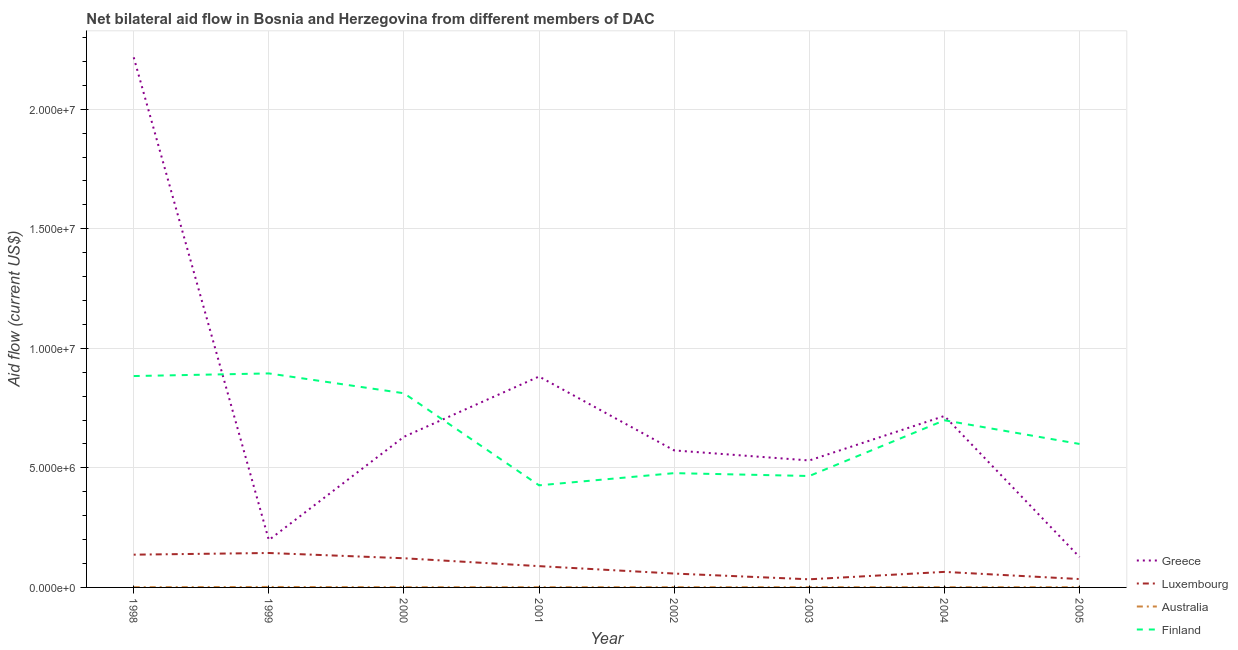Is the number of lines equal to the number of legend labels?
Provide a succinct answer. Yes. What is the amount of aid given by greece in 2001?
Give a very brief answer. 8.82e+06. Across all years, what is the maximum amount of aid given by luxembourg?
Offer a very short reply. 1.44e+06. Across all years, what is the minimum amount of aid given by luxembourg?
Your response must be concise. 3.40e+05. What is the total amount of aid given by luxembourg in the graph?
Keep it short and to the point. 6.84e+06. What is the difference between the amount of aid given by australia in 1998 and that in 2001?
Make the answer very short. 0. What is the difference between the amount of aid given by finland in 2000 and the amount of aid given by luxembourg in 1999?
Your response must be concise. 6.68e+06. What is the average amount of aid given by greece per year?
Offer a terse response. 7.34e+06. In the year 2000, what is the difference between the amount of aid given by greece and amount of aid given by australia?
Your response must be concise. 6.29e+06. In how many years, is the amount of aid given by luxembourg greater than 15000000 US$?
Offer a terse response. 0. What is the ratio of the amount of aid given by luxembourg in 1998 to that in 2002?
Your answer should be compact. 2.36. Is the amount of aid given by greece in 1998 less than that in 2005?
Offer a very short reply. No. What is the difference between the highest and the lowest amount of aid given by australia?
Make the answer very short. 10000. In how many years, is the amount of aid given by greece greater than the average amount of aid given by greece taken over all years?
Your answer should be compact. 2. Is it the case that in every year, the sum of the amount of aid given by australia and amount of aid given by greece is greater than the sum of amount of aid given by luxembourg and amount of aid given by finland?
Your answer should be compact. No. Is it the case that in every year, the sum of the amount of aid given by greece and amount of aid given by luxembourg is greater than the amount of aid given by australia?
Your answer should be compact. Yes. Does the amount of aid given by australia monotonically increase over the years?
Give a very brief answer. No. Is the amount of aid given by finland strictly greater than the amount of aid given by luxembourg over the years?
Provide a short and direct response. Yes. What is the difference between two consecutive major ticks on the Y-axis?
Offer a very short reply. 5.00e+06. Are the values on the major ticks of Y-axis written in scientific E-notation?
Provide a succinct answer. Yes. Does the graph contain any zero values?
Your response must be concise. No. Does the graph contain grids?
Keep it short and to the point. Yes. Where does the legend appear in the graph?
Make the answer very short. Bottom right. How many legend labels are there?
Provide a succinct answer. 4. How are the legend labels stacked?
Give a very brief answer. Vertical. What is the title of the graph?
Your answer should be compact. Net bilateral aid flow in Bosnia and Herzegovina from different members of DAC. Does "United States" appear as one of the legend labels in the graph?
Offer a very short reply. No. What is the Aid flow (current US$) in Greece in 1998?
Your answer should be very brief. 2.22e+07. What is the Aid flow (current US$) of Luxembourg in 1998?
Keep it short and to the point. 1.37e+06. What is the Aid flow (current US$) in Australia in 1998?
Make the answer very short. 10000. What is the Aid flow (current US$) of Finland in 1998?
Your answer should be compact. 8.84e+06. What is the Aid flow (current US$) in Greece in 1999?
Give a very brief answer. 1.98e+06. What is the Aid flow (current US$) of Luxembourg in 1999?
Your response must be concise. 1.44e+06. What is the Aid flow (current US$) in Finland in 1999?
Offer a terse response. 8.95e+06. What is the Aid flow (current US$) in Greece in 2000?
Provide a succinct answer. 6.30e+06. What is the Aid flow (current US$) in Luxembourg in 2000?
Your answer should be very brief. 1.22e+06. What is the Aid flow (current US$) of Australia in 2000?
Your answer should be compact. 10000. What is the Aid flow (current US$) in Finland in 2000?
Provide a short and direct response. 8.12e+06. What is the Aid flow (current US$) of Greece in 2001?
Provide a succinct answer. 8.82e+06. What is the Aid flow (current US$) of Luxembourg in 2001?
Provide a short and direct response. 8.90e+05. What is the Aid flow (current US$) of Australia in 2001?
Offer a very short reply. 10000. What is the Aid flow (current US$) of Finland in 2001?
Give a very brief answer. 4.27e+06. What is the Aid flow (current US$) of Greece in 2002?
Give a very brief answer. 5.73e+06. What is the Aid flow (current US$) in Luxembourg in 2002?
Provide a succinct answer. 5.80e+05. What is the Aid flow (current US$) of Finland in 2002?
Give a very brief answer. 4.78e+06. What is the Aid flow (current US$) of Greece in 2003?
Ensure brevity in your answer.  5.31e+06. What is the Aid flow (current US$) of Finland in 2003?
Provide a succinct answer. 4.66e+06. What is the Aid flow (current US$) in Greece in 2004?
Give a very brief answer. 7.17e+06. What is the Aid flow (current US$) of Luxembourg in 2004?
Give a very brief answer. 6.50e+05. What is the Aid flow (current US$) in Australia in 2004?
Provide a short and direct response. 10000. What is the Aid flow (current US$) in Finland in 2004?
Provide a short and direct response. 6.99e+06. What is the Aid flow (current US$) of Greece in 2005?
Give a very brief answer. 1.27e+06. What is the Aid flow (current US$) of Finland in 2005?
Make the answer very short. 6.00e+06. Across all years, what is the maximum Aid flow (current US$) of Greece?
Ensure brevity in your answer.  2.22e+07. Across all years, what is the maximum Aid flow (current US$) in Luxembourg?
Make the answer very short. 1.44e+06. Across all years, what is the maximum Aid flow (current US$) of Finland?
Give a very brief answer. 8.95e+06. Across all years, what is the minimum Aid flow (current US$) of Greece?
Provide a short and direct response. 1.27e+06. Across all years, what is the minimum Aid flow (current US$) of Australia?
Offer a terse response. 10000. Across all years, what is the minimum Aid flow (current US$) in Finland?
Keep it short and to the point. 4.27e+06. What is the total Aid flow (current US$) in Greece in the graph?
Provide a short and direct response. 5.88e+07. What is the total Aid flow (current US$) in Luxembourg in the graph?
Your response must be concise. 6.84e+06. What is the total Aid flow (current US$) in Finland in the graph?
Ensure brevity in your answer.  5.26e+07. What is the difference between the Aid flow (current US$) of Greece in 1998 and that in 1999?
Offer a very short reply. 2.02e+07. What is the difference between the Aid flow (current US$) in Luxembourg in 1998 and that in 1999?
Offer a terse response. -7.00e+04. What is the difference between the Aid flow (current US$) of Greece in 1998 and that in 2000?
Your answer should be very brief. 1.59e+07. What is the difference between the Aid flow (current US$) in Finland in 1998 and that in 2000?
Provide a short and direct response. 7.20e+05. What is the difference between the Aid flow (current US$) of Greece in 1998 and that in 2001?
Your answer should be very brief. 1.34e+07. What is the difference between the Aid flow (current US$) in Luxembourg in 1998 and that in 2001?
Offer a very short reply. 4.80e+05. What is the difference between the Aid flow (current US$) in Finland in 1998 and that in 2001?
Your response must be concise. 4.57e+06. What is the difference between the Aid flow (current US$) of Greece in 1998 and that in 2002?
Ensure brevity in your answer.  1.64e+07. What is the difference between the Aid flow (current US$) in Luxembourg in 1998 and that in 2002?
Make the answer very short. 7.90e+05. What is the difference between the Aid flow (current US$) of Australia in 1998 and that in 2002?
Make the answer very short. 0. What is the difference between the Aid flow (current US$) of Finland in 1998 and that in 2002?
Ensure brevity in your answer.  4.06e+06. What is the difference between the Aid flow (current US$) of Greece in 1998 and that in 2003?
Your answer should be compact. 1.69e+07. What is the difference between the Aid flow (current US$) of Luxembourg in 1998 and that in 2003?
Your answer should be compact. 1.03e+06. What is the difference between the Aid flow (current US$) in Australia in 1998 and that in 2003?
Ensure brevity in your answer.  0. What is the difference between the Aid flow (current US$) of Finland in 1998 and that in 2003?
Your answer should be very brief. 4.18e+06. What is the difference between the Aid flow (current US$) of Greece in 1998 and that in 2004?
Ensure brevity in your answer.  1.50e+07. What is the difference between the Aid flow (current US$) of Luxembourg in 1998 and that in 2004?
Make the answer very short. 7.20e+05. What is the difference between the Aid flow (current US$) in Finland in 1998 and that in 2004?
Your response must be concise. 1.85e+06. What is the difference between the Aid flow (current US$) in Greece in 1998 and that in 2005?
Offer a very short reply. 2.09e+07. What is the difference between the Aid flow (current US$) in Luxembourg in 1998 and that in 2005?
Ensure brevity in your answer.  1.02e+06. What is the difference between the Aid flow (current US$) of Australia in 1998 and that in 2005?
Keep it short and to the point. 0. What is the difference between the Aid flow (current US$) in Finland in 1998 and that in 2005?
Ensure brevity in your answer.  2.84e+06. What is the difference between the Aid flow (current US$) in Greece in 1999 and that in 2000?
Your answer should be very brief. -4.32e+06. What is the difference between the Aid flow (current US$) of Luxembourg in 1999 and that in 2000?
Your response must be concise. 2.20e+05. What is the difference between the Aid flow (current US$) in Australia in 1999 and that in 2000?
Offer a very short reply. 10000. What is the difference between the Aid flow (current US$) in Finland in 1999 and that in 2000?
Ensure brevity in your answer.  8.30e+05. What is the difference between the Aid flow (current US$) in Greece in 1999 and that in 2001?
Offer a very short reply. -6.84e+06. What is the difference between the Aid flow (current US$) in Luxembourg in 1999 and that in 2001?
Your answer should be very brief. 5.50e+05. What is the difference between the Aid flow (current US$) of Australia in 1999 and that in 2001?
Offer a very short reply. 10000. What is the difference between the Aid flow (current US$) of Finland in 1999 and that in 2001?
Ensure brevity in your answer.  4.68e+06. What is the difference between the Aid flow (current US$) of Greece in 1999 and that in 2002?
Your answer should be compact. -3.75e+06. What is the difference between the Aid flow (current US$) in Luxembourg in 1999 and that in 2002?
Offer a terse response. 8.60e+05. What is the difference between the Aid flow (current US$) in Finland in 1999 and that in 2002?
Your answer should be very brief. 4.17e+06. What is the difference between the Aid flow (current US$) of Greece in 1999 and that in 2003?
Make the answer very short. -3.33e+06. What is the difference between the Aid flow (current US$) of Luxembourg in 1999 and that in 2003?
Your response must be concise. 1.10e+06. What is the difference between the Aid flow (current US$) of Australia in 1999 and that in 2003?
Your answer should be very brief. 10000. What is the difference between the Aid flow (current US$) in Finland in 1999 and that in 2003?
Keep it short and to the point. 4.29e+06. What is the difference between the Aid flow (current US$) of Greece in 1999 and that in 2004?
Provide a short and direct response. -5.19e+06. What is the difference between the Aid flow (current US$) in Luxembourg in 1999 and that in 2004?
Provide a succinct answer. 7.90e+05. What is the difference between the Aid flow (current US$) of Finland in 1999 and that in 2004?
Give a very brief answer. 1.96e+06. What is the difference between the Aid flow (current US$) of Greece in 1999 and that in 2005?
Your response must be concise. 7.10e+05. What is the difference between the Aid flow (current US$) of Luxembourg in 1999 and that in 2005?
Offer a terse response. 1.09e+06. What is the difference between the Aid flow (current US$) in Australia in 1999 and that in 2005?
Provide a succinct answer. 10000. What is the difference between the Aid flow (current US$) of Finland in 1999 and that in 2005?
Keep it short and to the point. 2.95e+06. What is the difference between the Aid flow (current US$) of Greece in 2000 and that in 2001?
Your answer should be compact. -2.52e+06. What is the difference between the Aid flow (current US$) of Finland in 2000 and that in 2001?
Keep it short and to the point. 3.85e+06. What is the difference between the Aid flow (current US$) of Greece in 2000 and that in 2002?
Your answer should be very brief. 5.70e+05. What is the difference between the Aid flow (current US$) in Luxembourg in 2000 and that in 2002?
Provide a succinct answer. 6.40e+05. What is the difference between the Aid flow (current US$) of Finland in 2000 and that in 2002?
Your answer should be very brief. 3.34e+06. What is the difference between the Aid flow (current US$) in Greece in 2000 and that in 2003?
Your response must be concise. 9.90e+05. What is the difference between the Aid flow (current US$) of Luxembourg in 2000 and that in 2003?
Make the answer very short. 8.80e+05. What is the difference between the Aid flow (current US$) of Finland in 2000 and that in 2003?
Ensure brevity in your answer.  3.46e+06. What is the difference between the Aid flow (current US$) of Greece in 2000 and that in 2004?
Keep it short and to the point. -8.70e+05. What is the difference between the Aid flow (current US$) in Luxembourg in 2000 and that in 2004?
Give a very brief answer. 5.70e+05. What is the difference between the Aid flow (current US$) of Finland in 2000 and that in 2004?
Make the answer very short. 1.13e+06. What is the difference between the Aid flow (current US$) of Greece in 2000 and that in 2005?
Your answer should be very brief. 5.03e+06. What is the difference between the Aid flow (current US$) in Luxembourg in 2000 and that in 2005?
Your response must be concise. 8.70e+05. What is the difference between the Aid flow (current US$) in Finland in 2000 and that in 2005?
Give a very brief answer. 2.12e+06. What is the difference between the Aid flow (current US$) of Greece in 2001 and that in 2002?
Provide a succinct answer. 3.09e+06. What is the difference between the Aid flow (current US$) in Luxembourg in 2001 and that in 2002?
Give a very brief answer. 3.10e+05. What is the difference between the Aid flow (current US$) of Finland in 2001 and that in 2002?
Give a very brief answer. -5.10e+05. What is the difference between the Aid flow (current US$) in Greece in 2001 and that in 2003?
Your answer should be very brief. 3.51e+06. What is the difference between the Aid flow (current US$) of Luxembourg in 2001 and that in 2003?
Provide a succinct answer. 5.50e+05. What is the difference between the Aid flow (current US$) of Australia in 2001 and that in 2003?
Keep it short and to the point. 0. What is the difference between the Aid flow (current US$) of Finland in 2001 and that in 2003?
Make the answer very short. -3.90e+05. What is the difference between the Aid flow (current US$) of Greece in 2001 and that in 2004?
Make the answer very short. 1.65e+06. What is the difference between the Aid flow (current US$) of Australia in 2001 and that in 2004?
Give a very brief answer. 0. What is the difference between the Aid flow (current US$) in Finland in 2001 and that in 2004?
Give a very brief answer. -2.72e+06. What is the difference between the Aid flow (current US$) of Greece in 2001 and that in 2005?
Ensure brevity in your answer.  7.55e+06. What is the difference between the Aid flow (current US$) in Luxembourg in 2001 and that in 2005?
Provide a succinct answer. 5.40e+05. What is the difference between the Aid flow (current US$) of Australia in 2001 and that in 2005?
Make the answer very short. 0. What is the difference between the Aid flow (current US$) in Finland in 2001 and that in 2005?
Your answer should be compact. -1.73e+06. What is the difference between the Aid flow (current US$) of Australia in 2002 and that in 2003?
Provide a short and direct response. 0. What is the difference between the Aid flow (current US$) of Greece in 2002 and that in 2004?
Keep it short and to the point. -1.44e+06. What is the difference between the Aid flow (current US$) of Luxembourg in 2002 and that in 2004?
Offer a very short reply. -7.00e+04. What is the difference between the Aid flow (current US$) in Australia in 2002 and that in 2004?
Ensure brevity in your answer.  0. What is the difference between the Aid flow (current US$) in Finland in 2002 and that in 2004?
Your response must be concise. -2.21e+06. What is the difference between the Aid flow (current US$) of Greece in 2002 and that in 2005?
Make the answer very short. 4.46e+06. What is the difference between the Aid flow (current US$) in Luxembourg in 2002 and that in 2005?
Keep it short and to the point. 2.30e+05. What is the difference between the Aid flow (current US$) of Finland in 2002 and that in 2005?
Give a very brief answer. -1.22e+06. What is the difference between the Aid flow (current US$) in Greece in 2003 and that in 2004?
Offer a very short reply. -1.86e+06. What is the difference between the Aid flow (current US$) of Luxembourg in 2003 and that in 2004?
Offer a terse response. -3.10e+05. What is the difference between the Aid flow (current US$) of Finland in 2003 and that in 2004?
Provide a succinct answer. -2.33e+06. What is the difference between the Aid flow (current US$) in Greece in 2003 and that in 2005?
Keep it short and to the point. 4.04e+06. What is the difference between the Aid flow (current US$) of Finland in 2003 and that in 2005?
Your answer should be very brief. -1.34e+06. What is the difference between the Aid flow (current US$) of Greece in 2004 and that in 2005?
Offer a terse response. 5.90e+06. What is the difference between the Aid flow (current US$) in Luxembourg in 2004 and that in 2005?
Offer a very short reply. 3.00e+05. What is the difference between the Aid flow (current US$) in Australia in 2004 and that in 2005?
Your answer should be very brief. 0. What is the difference between the Aid flow (current US$) in Finland in 2004 and that in 2005?
Offer a terse response. 9.90e+05. What is the difference between the Aid flow (current US$) in Greece in 1998 and the Aid flow (current US$) in Luxembourg in 1999?
Your answer should be very brief. 2.07e+07. What is the difference between the Aid flow (current US$) in Greece in 1998 and the Aid flow (current US$) in Australia in 1999?
Give a very brief answer. 2.22e+07. What is the difference between the Aid flow (current US$) of Greece in 1998 and the Aid flow (current US$) of Finland in 1999?
Make the answer very short. 1.32e+07. What is the difference between the Aid flow (current US$) in Luxembourg in 1998 and the Aid flow (current US$) in Australia in 1999?
Make the answer very short. 1.35e+06. What is the difference between the Aid flow (current US$) of Luxembourg in 1998 and the Aid flow (current US$) of Finland in 1999?
Give a very brief answer. -7.58e+06. What is the difference between the Aid flow (current US$) of Australia in 1998 and the Aid flow (current US$) of Finland in 1999?
Make the answer very short. -8.94e+06. What is the difference between the Aid flow (current US$) in Greece in 1998 and the Aid flow (current US$) in Luxembourg in 2000?
Your response must be concise. 2.10e+07. What is the difference between the Aid flow (current US$) of Greece in 1998 and the Aid flow (current US$) of Australia in 2000?
Give a very brief answer. 2.22e+07. What is the difference between the Aid flow (current US$) of Greece in 1998 and the Aid flow (current US$) of Finland in 2000?
Offer a terse response. 1.40e+07. What is the difference between the Aid flow (current US$) in Luxembourg in 1998 and the Aid flow (current US$) in Australia in 2000?
Provide a succinct answer. 1.36e+06. What is the difference between the Aid flow (current US$) of Luxembourg in 1998 and the Aid flow (current US$) of Finland in 2000?
Your answer should be very brief. -6.75e+06. What is the difference between the Aid flow (current US$) in Australia in 1998 and the Aid flow (current US$) in Finland in 2000?
Offer a terse response. -8.11e+06. What is the difference between the Aid flow (current US$) in Greece in 1998 and the Aid flow (current US$) in Luxembourg in 2001?
Provide a succinct answer. 2.13e+07. What is the difference between the Aid flow (current US$) of Greece in 1998 and the Aid flow (current US$) of Australia in 2001?
Your answer should be very brief. 2.22e+07. What is the difference between the Aid flow (current US$) in Greece in 1998 and the Aid flow (current US$) in Finland in 2001?
Offer a very short reply. 1.79e+07. What is the difference between the Aid flow (current US$) of Luxembourg in 1998 and the Aid flow (current US$) of Australia in 2001?
Your answer should be very brief. 1.36e+06. What is the difference between the Aid flow (current US$) in Luxembourg in 1998 and the Aid flow (current US$) in Finland in 2001?
Offer a very short reply. -2.90e+06. What is the difference between the Aid flow (current US$) in Australia in 1998 and the Aid flow (current US$) in Finland in 2001?
Make the answer very short. -4.26e+06. What is the difference between the Aid flow (current US$) of Greece in 1998 and the Aid flow (current US$) of Luxembourg in 2002?
Your answer should be very brief. 2.16e+07. What is the difference between the Aid flow (current US$) in Greece in 1998 and the Aid flow (current US$) in Australia in 2002?
Offer a terse response. 2.22e+07. What is the difference between the Aid flow (current US$) in Greece in 1998 and the Aid flow (current US$) in Finland in 2002?
Offer a very short reply. 1.74e+07. What is the difference between the Aid flow (current US$) of Luxembourg in 1998 and the Aid flow (current US$) of Australia in 2002?
Your response must be concise. 1.36e+06. What is the difference between the Aid flow (current US$) of Luxembourg in 1998 and the Aid flow (current US$) of Finland in 2002?
Your answer should be compact. -3.41e+06. What is the difference between the Aid flow (current US$) in Australia in 1998 and the Aid flow (current US$) in Finland in 2002?
Your answer should be very brief. -4.77e+06. What is the difference between the Aid flow (current US$) of Greece in 1998 and the Aid flow (current US$) of Luxembourg in 2003?
Make the answer very short. 2.18e+07. What is the difference between the Aid flow (current US$) in Greece in 1998 and the Aid flow (current US$) in Australia in 2003?
Give a very brief answer. 2.22e+07. What is the difference between the Aid flow (current US$) of Greece in 1998 and the Aid flow (current US$) of Finland in 2003?
Provide a short and direct response. 1.75e+07. What is the difference between the Aid flow (current US$) in Luxembourg in 1998 and the Aid flow (current US$) in Australia in 2003?
Provide a short and direct response. 1.36e+06. What is the difference between the Aid flow (current US$) in Luxembourg in 1998 and the Aid flow (current US$) in Finland in 2003?
Your answer should be compact. -3.29e+06. What is the difference between the Aid flow (current US$) in Australia in 1998 and the Aid flow (current US$) in Finland in 2003?
Your answer should be very brief. -4.65e+06. What is the difference between the Aid flow (current US$) in Greece in 1998 and the Aid flow (current US$) in Luxembourg in 2004?
Give a very brief answer. 2.15e+07. What is the difference between the Aid flow (current US$) of Greece in 1998 and the Aid flow (current US$) of Australia in 2004?
Ensure brevity in your answer.  2.22e+07. What is the difference between the Aid flow (current US$) of Greece in 1998 and the Aid flow (current US$) of Finland in 2004?
Provide a succinct answer. 1.52e+07. What is the difference between the Aid flow (current US$) in Luxembourg in 1998 and the Aid flow (current US$) in Australia in 2004?
Ensure brevity in your answer.  1.36e+06. What is the difference between the Aid flow (current US$) of Luxembourg in 1998 and the Aid flow (current US$) of Finland in 2004?
Make the answer very short. -5.62e+06. What is the difference between the Aid flow (current US$) in Australia in 1998 and the Aid flow (current US$) in Finland in 2004?
Give a very brief answer. -6.98e+06. What is the difference between the Aid flow (current US$) in Greece in 1998 and the Aid flow (current US$) in Luxembourg in 2005?
Provide a succinct answer. 2.18e+07. What is the difference between the Aid flow (current US$) in Greece in 1998 and the Aid flow (current US$) in Australia in 2005?
Ensure brevity in your answer.  2.22e+07. What is the difference between the Aid flow (current US$) in Greece in 1998 and the Aid flow (current US$) in Finland in 2005?
Offer a terse response. 1.62e+07. What is the difference between the Aid flow (current US$) in Luxembourg in 1998 and the Aid flow (current US$) in Australia in 2005?
Provide a succinct answer. 1.36e+06. What is the difference between the Aid flow (current US$) in Luxembourg in 1998 and the Aid flow (current US$) in Finland in 2005?
Provide a succinct answer. -4.63e+06. What is the difference between the Aid flow (current US$) in Australia in 1998 and the Aid flow (current US$) in Finland in 2005?
Your answer should be compact. -5.99e+06. What is the difference between the Aid flow (current US$) of Greece in 1999 and the Aid flow (current US$) of Luxembourg in 2000?
Ensure brevity in your answer.  7.60e+05. What is the difference between the Aid flow (current US$) in Greece in 1999 and the Aid flow (current US$) in Australia in 2000?
Ensure brevity in your answer.  1.97e+06. What is the difference between the Aid flow (current US$) in Greece in 1999 and the Aid flow (current US$) in Finland in 2000?
Your answer should be very brief. -6.14e+06. What is the difference between the Aid flow (current US$) in Luxembourg in 1999 and the Aid flow (current US$) in Australia in 2000?
Offer a very short reply. 1.43e+06. What is the difference between the Aid flow (current US$) in Luxembourg in 1999 and the Aid flow (current US$) in Finland in 2000?
Your answer should be very brief. -6.68e+06. What is the difference between the Aid flow (current US$) of Australia in 1999 and the Aid flow (current US$) of Finland in 2000?
Keep it short and to the point. -8.10e+06. What is the difference between the Aid flow (current US$) of Greece in 1999 and the Aid flow (current US$) of Luxembourg in 2001?
Offer a very short reply. 1.09e+06. What is the difference between the Aid flow (current US$) in Greece in 1999 and the Aid flow (current US$) in Australia in 2001?
Your response must be concise. 1.97e+06. What is the difference between the Aid flow (current US$) of Greece in 1999 and the Aid flow (current US$) of Finland in 2001?
Provide a succinct answer. -2.29e+06. What is the difference between the Aid flow (current US$) of Luxembourg in 1999 and the Aid flow (current US$) of Australia in 2001?
Keep it short and to the point. 1.43e+06. What is the difference between the Aid flow (current US$) in Luxembourg in 1999 and the Aid flow (current US$) in Finland in 2001?
Keep it short and to the point. -2.83e+06. What is the difference between the Aid flow (current US$) of Australia in 1999 and the Aid flow (current US$) of Finland in 2001?
Your answer should be very brief. -4.25e+06. What is the difference between the Aid flow (current US$) of Greece in 1999 and the Aid flow (current US$) of Luxembourg in 2002?
Give a very brief answer. 1.40e+06. What is the difference between the Aid flow (current US$) in Greece in 1999 and the Aid flow (current US$) in Australia in 2002?
Your answer should be compact. 1.97e+06. What is the difference between the Aid flow (current US$) in Greece in 1999 and the Aid flow (current US$) in Finland in 2002?
Provide a succinct answer. -2.80e+06. What is the difference between the Aid flow (current US$) in Luxembourg in 1999 and the Aid flow (current US$) in Australia in 2002?
Ensure brevity in your answer.  1.43e+06. What is the difference between the Aid flow (current US$) in Luxembourg in 1999 and the Aid flow (current US$) in Finland in 2002?
Your response must be concise. -3.34e+06. What is the difference between the Aid flow (current US$) in Australia in 1999 and the Aid flow (current US$) in Finland in 2002?
Provide a succinct answer. -4.76e+06. What is the difference between the Aid flow (current US$) in Greece in 1999 and the Aid flow (current US$) in Luxembourg in 2003?
Provide a succinct answer. 1.64e+06. What is the difference between the Aid flow (current US$) in Greece in 1999 and the Aid flow (current US$) in Australia in 2003?
Provide a succinct answer. 1.97e+06. What is the difference between the Aid flow (current US$) in Greece in 1999 and the Aid flow (current US$) in Finland in 2003?
Your response must be concise. -2.68e+06. What is the difference between the Aid flow (current US$) of Luxembourg in 1999 and the Aid flow (current US$) of Australia in 2003?
Ensure brevity in your answer.  1.43e+06. What is the difference between the Aid flow (current US$) of Luxembourg in 1999 and the Aid flow (current US$) of Finland in 2003?
Give a very brief answer. -3.22e+06. What is the difference between the Aid flow (current US$) in Australia in 1999 and the Aid flow (current US$) in Finland in 2003?
Your response must be concise. -4.64e+06. What is the difference between the Aid flow (current US$) of Greece in 1999 and the Aid flow (current US$) of Luxembourg in 2004?
Give a very brief answer. 1.33e+06. What is the difference between the Aid flow (current US$) in Greece in 1999 and the Aid flow (current US$) in Australia in 2004?
Provide a short and direct response. 1.97e+06. What is the difference between the Aid flow (current US$) in Greece in 1999 and the Aid flow (current US$) in Finland in 2004?
Offer a terse response. -5.01e+06. What is the difference between the Aid flow (current US$) in Luxembourg in 1999 and the Aid flow (current US$) in Australia in 2004?
Give a very brief answer. 1.43e+06. What is the difference between the Aid flow (current US$) of Luxembourg in 1999 and the Aid flow (current US$) of Finland in 2004?
Give a very brief answer. -5.55e+06. What is the difference between the Aid flow (current US$) in Australia in 1999 and the Aid flow (current US$) in Finland in 2004?
Give a very brief answer. -6.97e+06. What is the difference between the Aid flow (current US$) of Greece in 1999 and the Aid flow (current US$) of Luxembourg in 2005?
Give a very brief answer. 1.63e+06. What is the difference between the Aid flow (current US$) of Greece in 1999 and the Aid flow (current US$) of Australia in 2005?
Give a very brief answer. 1.97e+06. What is the difference between the Aid flow (current US$) in Greece in 1999 and the Aid flow (current US$) in Finland in 2005?
Offer a terse response. -4.02e+06. What is the difference between the Aid flow (current US$) in Luxembourg in 1999 and the Aid flow (current US$) in Australia in 2005?
Ensure brevity in your answer.  1.43e+06. What is the difference between the Aid flow (current US$) in Luxembourg in 1999 and the Aid flow (current US$) in Finland in 2005?
Provide a succinct answer. -4.56e+06. What is the difference between the Aid flow (current US$) in Australia in 1999 and the Aid flow (current US$) in Finland in 2005?
Provide a succinct answer. -5.98e+06. What is the difference between the Aid flow (current US$) of Greece in 2000 and the Aid flow (current US$) of Luxembourg in 2001?
Your answer should be compact. 5.41e+06. What is the difference between the Aid flow (current US$) of Greece in 2000 and the Aid flow (current US$) of Australia in 2001?
Offer a terse response. 6.29e+06. What is the difference between the Aid flow (current US$) of Greece in 2000 and the Aid flow (current US$) of Finland in 2001?
Give a very brief answer. 2.03e+06. What is the difference between the Aid flow (current US$) in Luxembourg in 2000 and the Aid flow (current US$) in Australia in 2001?
Your answer should be very brief. 1.21e+06. What is the difference between the Aid flow (current US$) of Luxembourg in 2000 and the Aid flow (current US$) of Finland in 2001?
Provide a short and direct response. -3.05e+06. What is the difference between the Aid flow (current US$) of Australia in 2000 and the Aid flow (current US$) of Finland in 2001?
Give a very brief answer. -4.26e+06. What is the difference between the Aid flow (current US$) in Greece in 2000 and the Aid flow (current US$) in Luxembourg in 2002?
Offer a very short reply. 5.72e+06. What is the difference between the Aid flow (current US$) of Greece in 2000 and the Aid flow (current US$) of Australia in 2002?
Give a very brief answer. 6.29e+06. What is the difference between the Aid flow (current US$) of Greece in 2000 and the Aid flow (current US$) of Finland in 2002?
Make the answer very short. 1.52e+06. What is the difference between the Aid flow (current US$) of Luxembourg in 2000 and the Aid flow (current US$) of Australia in 2002?
Provide a succinct answer. 1.21e+06. What is the difference between the Aid flow (current US$) of Luxembourg in 2000 and the Aid flow (current US$) of Finland in 2002?
Provide a succinct answer. -3.56e+06. What is the difference between the Aid flow (current US$) of Australia in 2000 and the Aid flow (current US$) of Finland in 2002?
Your answer should be very brief. -4.77e+06. What is the difference between the Aid flow (current US$) of Greece in 2000 and the Aid flow (current US$) of Luxembourg in 2003?
Your response must be concise. 5.96e+06. What is the difference between the Aid flow (current US$) of Greece in 2000 and the Aid flow (current US$) of Australia in 2003?
Ensure brevity in your answer.  6.29e+06. What is the difference between the Aid flow (current US$) in Greece in 2000 and the Aid flow (current US$) in Finland in 2003?
Offer a very short reply. 1.64e+06. What is the difference between the Aid flow (current US$) of Luxembourg in 2000 and the Aid flow (current US$) of Australia in 2003?
Offer a very short reply. 1.21e+06. What is the difference between the Aid flow (current US$) of Luxembourg in 2000 and the Aid flow (current US$) of Finland in 2003?
Keep it short and to the point. -3.44e+06. What is the difference between the Aid flow (current US$) of Australia in 2000 and the Aid flow (current US$) of Finland in 2003?
Provide a succinct answer. -4.65e+06. What is the difference between the Aid flow (current US$) in Greece in 2000 and the Aid flow (current US$) in Luxembourg in 2004?
Keep it short and to the point. 5.65e+06. What is the difference between the Aid flow (current US$) of Greece in 2000 and the Aid flow (current US$) of Australia in 2004?
Your response must be concise. 6.29e+06. What is the difference between the Aid flow (current US$) in Greece in 2000 and the Aid flow (current US$) in Finland in 2004?
Provide a succinct answer. -6.90e+05. What is the difference between the Aid flow (current US$) of Luxembourg in 2000 and the Aid flow (current US$) of Australia in 2004?
Provide a succinct answer. 1.21e+06. What is the difference between the Aid flow (current US$) in Luxembourg in 2000 and the Aid flow (current US$) in Finland in 2004?
Keep it short and to the point. -5.77e+06. What is the difference between the Aid flow (current US$) of Australia in 2000 and the Aid flow (current US$) of Finland in 2004?
Ensure brevity in your answer.  -6.98e+06. What is the difference between the Aid flow (current US$) in Greece in 2000 and the Aid flow (current US$) in Luxembourg in 2005?
Your response must be concise. 5.95e+06. What is the difference between the Aid flow (current US$) of Greece in 2000 and the Aid flow (current US$) of Australia in 2005?
Offer a terse response. 6.29e+06. What is the difference between the Aid flow (current US$) in Luxembourg in 2000 and the Aid flow (current US$) in Australia in 2005?
Your response must be concise. 1.21e+06. What is the difference between the Aid flow (current US$) of Luxembourg in 2000 and the Aid flow (current US$) of Finland in 2005?
Ensure brevity in your answer.  -4.78e+06. What is the difference between the Aid flow (current US$) of Australia in 2000 and the Aid flow (current US$) of Finland in 2005?
Give a very brief answer. -5.99e+06. What is the difference between the Aid flow (current US$) in Greece in 2001 and the Aid flow (current US$) in Luxembourg in 2002?
Your answer should be very brief. 8.24e+06. What is the difference between the Aid flow (current US$) of Greece in 2001 and the Aid flow (current US$) of Australia in 2002?
Your response must be concise. 8.81e+06. What is the difference between the Aid flow (current US$) of Greece in 2001 and the Aid flow (current US$) of Finland in 2002?
Your answer should be very brief. 4.04e+06. What is the difference between the Aid flow (current US$) in Luxembourg in 2001 and the Aid flow (current US$) in Australia in 2002?
Your answer should be very brief. 8.80e+05. What is the difference between the Aid flow (current US$) in Luxembourg in 2001 and the Aid flow (current US$) in Finland in 2002?
Ensure brevity in your answer.  -3.89e+06. What is the difference between the Aid flow (current US$) in Australia in 2001 and the Aid flow (current US$) in Finland in 2002?
Your answer should be compact. -4.77e+06. What is the difference between the Aid flow (current US$) in Greece in 2001 and the Aid flow (current US$) in Luxembourg in 2003?
Your answer should be compact. 8.48e+06. What is the difference between the Aid flow (current US$) of Greece in 2001 and the Aid flow (current US$) of Australia in 2003?
Keep it short and to the point. 8.81e+06. What is the difference between the Aid flow (current US$) of Greece in 2001 and the Aid flow (current US$) of Finland in 2003?
Offer a terse response. 4.16e+06. What is the difference between the Aid flow (current US$) in Luxembourg in 2001 and the Aid flow (current US$) in Australia in 2003?
Your answer should be compact. 8.80e+05. What is the difference between the Aid flow (current US$) in Luxembourg in 2001 and the Aid flow (current US$) in Finland in 2003?
Give a very brief answer. -3.77e+06. What is the difference between the Aid flow (current US$) of Australia in 2001 and the Aid flow (current US$) of Finland in 2003?
Provide a short and direct response. -4.65e+06. What is the difference between the Aid flow (current US$) in Greece in 2001 and the Aid flow (current US$) in Luxembourg in 2004?
Give a very brief answer. 8.17e+06. What is the difference between the Aid flow (current US$) of Greece in 2001 and the Aid flow (current US$) of Australia in 2004?
Make the answer very short. 8.81e+06. What is the difference between the Aid flow (current US$) in Greece in 2001 and the Aid flow (current US$) in Finland in 2004?
Ensure brevity in your answer.  1.83e+06. What is the difference between the Aid flow (current US$) of Luxembourg in 2001 and the Aid flow (current US$) of Australia in 2004?
Give a very brief answer. 8.80e+05. What is the difference between the Aid flow (current US$) of Luxembourg in 2001 and the Aid flow (current US$) of Finland in 2004?
Your answer should be compact. -6.10e+06. What is the difference between the Aid flow (current US$) in Australia in 2001 and the Aid flow (current US$) in Finland in 2004?
Ensure brevity in your answer.  -6.98e+06. What is the difference between the Aid flow (current US$) of Greece in 2001 and the Aid flow (current US$) of Luxembourg in 2005?
Keep it short and to the point. 8.47e+06. What is the difference between the Aid flow (current US$) of Greece in 2001 and the Aid flow (current US$) of Australia in 2005?
Your answer should be very brief. 8.81e+06. What is the difference between the Aid flow (current US$) of Greece in 2001 and the Aid flow (current US$) of Finland in 2005?
Your answer should be compact. 2.82e+06. What is the difference between the Aid flow (current US$) of Luxembourg in 2001 and the Aid flow (current US$) of Australia in 2005?
Your answer should be very brief. 8.80e+05. What is the difference between the Aid flow (current US$) of Luxembourg in 2001 and the Aid flow (current US$) of Finland in 2005?
Your response must be concise. -5.11e+06. What is the difference between the Aid flow (current US$) of Australia in 2001 and the Aid flow (current US$) of Finland in 2005?
Your response must be concise. -5.99e+06. What is the difference between the Aid flow (current US$) of Greece in 2002 and the Aid flow (current US$) of Luxembourg in 2003?
Give a very brief answer. 5.39e+06. What is the difference between the Aid flow (current US$) of Greece in 2002 and the Aid flow (current US$) of Australia in 2003?
Provide a succinct answer. 5.72e+06. What is the difference between the Aid flow (current US$) in Greece in 2002 and the Aid flow (current US$) in Finland in 2003?
Your answer should be very brief. 1.07e+06. What is the difference between the Aid flow (current US$) in Luxembourg in 2002 and the Aid flow (current US$) in Australia in 2003?
Keep it short and to the point. 5.70e+05. What is the difference between the Aid flow (current US$) of Luxembourg in 2002 and the Aid flow (current US$) of Finland in 2003?
Ensure brevity in your answer.  -4.08e+06. What is the difference between the Aid flow (current US$) of Australia in 2002 and the Aid flow (current US$) of Finland in 2003?
Your answer should be compact. -4.65e+06. What is the difference between the Aid flow (current US$) of Greece in 2002 and the Aid flow (current US$) of Luxembourg in 2004?
Your answer should be very brief. 5.08e+06. What is the difference between the Aid flow (current US$) of Greece in 2002 and the Aid flow (current US$) of Australia in 2004?
Give a very brief answer. 5.72e+06. What is the difference between the Aid flow (current US$) of Greece in 2002 and the Aid flow (current US$) of Finland in 2004?
Provide a succinct answer. -1.26e+06. What is the difference between the Aid flow (current US$) of Luxembourg in 2002 and the Aid flow (current US$) of Australia in 2004?
Offer a terse response. 5.70e+05. What is the difference between the Aid flow (current US$) in Luxembourg in 2002 and the Aid flow (current US$) in Finland in 2004?
Provide a succinct answer. -6.41e+06. What is the difference between the Aid flow (current US$) in Australia in 2002 and the Aid flow (current US$) in Finland in 2004?
Provide a short and direct response. -6.98e+06. What is the difference between the Aid flow (current US$) in Greece in 2002 and the Aid flow (current US$) in Luxembourg in 2005?
Keep it short and to the point. 5.38e+06. What is the difference between the Aid flow (current US$) in Greece in 2002 and the Aid flow (current US$) in Australia in 2005?
Give a very brief answer. 5.72e+06. What is the difference between the Aid flow (current US$) of Luxembourg in 2002 and the Aid flow (current US$) of Australia in 2005?
Provide a succinct answer. 5.70e+05. What is the difference between the Aid flow (current US$) of Luxembourg in 2002 and the Aid flow (current US$) of Finland in 2005?
Provide a succinct answer. -5.42e+06. What is the difference between the Aid flow (current US$) of Australia in 2002 and the Aid flow (current US$) of Finland in 2005?
Ensure brevity in your answer.  -5.99e+06. What is the difference between the Aid flow (current US$) of Greece in 2003 and the Aid flow (current US$) of Luxembourg in 2004?
Your response must be concise. 4.66e+06. What is the difference between the Aid flow (current US$) of Greece in 2003 and the Aid flow (current US$) of Australia in 2004?
Offer a terse response. 5.30e+06. What is the difference between the Aid flow (current US$) in Greece in 2003 and the Aid flow (current US$) in Finland in 2004?
Your answer should be very brief. -1.68e+06. What is the difference between the Aid flow (current US$) of Luxembourg in 2003 and the Aid flow (current US$) of Australia in 2004?
Make the answer very short. 3.30e+05. What is the difference between the Aid flow (current US$) in Luxembourg in 2003 and the Aid flow (current US$) in Finland in 2004?
Keep it short and to the point. -6.65e+06. What is the difference between the Aid flow (current US$) in Australia in 2003 and the Aid flow (current US$) in Finland in 2004?
Ensure brevity in your answer.  -6.98e+06. What is the difference between the Aid flow (current US$) of Greece in 2003 and the Aid flow (current US$) of Luxembourg in 2005?
Make the answer very short. 4.96e+06. What is the difference between the Aid flow (current US$) of Greece in 2003 and the Aid flow (current US$) of Australia in 2005?
Offer a very short reply. 5.30e+06. What is the difference between the Aid flow (current US$) in Greece in 2003 and the Aid flow (current US$) in Finland in 2005?
Make the answer very short. -6.90e+05. What is the difference between the Aid flow (current US$) of Luxembourg in 2003 and the Aid flow (current US$) of Finland in 2005?
Your response must be concise. -5.66e+06. What is the difference between the Aid flow (current US$) in Australia in 2003 and the Aid flow (current US$) in Finland in 2005?
Provide a succinct answer. -5.99e+06. What is the difference between the Aid flow (current US$) in Greece in 2004 and the Aid flow (current US$) in Luxembourg in 2005?
Provide a short and direct response. 6.82e+06. What is the difference between the Aid flow (current US$) in Greece in 2004 and the Aid flow (current US$) in Australia in 2005?
Give a very brief answer. 7.16e+06. What is the difference between the Aid flow (current US$) in Greece in 2004 and the Aid flow (current US$) in Finland in 2005?
Give a very brief answer. 1.17e+06. What is the difference between the Aid flow (current US$) in Luxembourg in 2004 and the Aid flow (current US$) in Australia in 2005?
Give a very brief answer. 6.40e+05. What is the difference between the Aid flow (current US$) in Luxembourg in 2004 and the Aid flow (current US$) in Finland in 2005?
Give a very brief answer. -5.35e+06. What is the difference between the Aid flow (current US$) in Australia in 2004 and the Aid flow (current US$) in Finland in 2005?
Make the answer very short. -5.99e+06. What is the average Aid flow (current US$) of Greece per year?
Ensure brevity in your answer.  7.34e+06. What is the average Aid flow (current US$) in Luxembourg per year?
Your answer should be compact. 8.55e+05. What is the average Aid flow (current US$) of Australia per year?
Your answer should be very brief. 1.12e+04. What is the average Aid flow (current US$) in Finland per year?
Your answer should be compact. 6.58e+06. In the year 1998, what is the difference between the Aid flow (current US$) of Greece and Aid flow (current US$) of Luxembourg?
Offer a terse response. 2.08e+07. In the year 1998, what is the difference between the Aid flow (current US$) in Greece and Aid flow (current US$) in Australia?
Offer a very short reply. 2.22e+07. In the year 1998, what is the difference between the Aid flow (current US$) in Greece and Aid flow (current US$) in Finland?
Provide a succinct answer. 1.33e+07. In the year 1998, what is the difference between the Aid flow (current US$) in Luxembourg and Aid flow (current US$) in Australia?
Give a very brief answer. 1.36e+06. In the year 1998, what is the difference between the Aid flow (current US$) in Luxembourg and Aid flow (current US$) in Finland?
Keep it short and to the point. -7.47e+06. In the year 1998, what is the difference between the Aid flow (current US$) of Australia and Aid flow (current US$) of Finland?
Make the answer very short. -8.83e+06. In the year 1999, what is the difference between the Aid flow (current US$) of Greece and Aid flow (current US$) of Luxembourg?
Ensure brevity in your answer.  5.40e+05. In the year 1999, what is the difference between the Aid flow (current US$) of Greece and Aid flow (current US$) of Australia?
Your response must be concise. 1.96e+06. In the year 1999, what is the difference between the Aid flow (current US$) in Greece and Aid flow (current US$) in Finland?
Offer a very short reply. -6.97e+06. In the year 1999, what is the difference between the Aid flow (current US$) in Luxembourg and Aid flow (current US$) in Australia?
Offer a terse response. 1.42e+06. In the year 1999, what is the difference between the Aid flow (current US$) of Luxembourg and Aid flow (current US$) of Finland?
Provide a short and direct response. -7.51e+06. In the year 1999, what is the difference between the Aid flow (current US$) of Australia and Aid flow (current US$) of Finland?
Your answer should be compact. -8.93e+06. In the year 2000, what is the difference between the Aid flow (current US$) of Greece and Aid flow (current US$) of Luxembourg?
Your answer should be very brief. 5.08e+06. In the year 2000, what is the difference between the Aid flow (current US$) of Greece and Aid flow (current US$) of Australia?
Provide a short and direct response. 6.29e+06. In the year 2000, what is the difference between the Aid flow (current US$) in Greece and Aid flow (current US$) in Finland?
Give a very brief answer. -1.82e+06. In the year 2000, what is the difference between the Aid flow (current US$) in Luxembourg and Aid flow (current US$) in Australia?
Give a very brief answer. 1.21e+06. In the year 2000, what is the difference between the Aid flow (current US$) in Luxembourg and Aid flow (current US$) in Finland?
Your response must be concise. -6.90e+06. In the year 2000, what is the difference between the Aid flow (current US$) in Australia and Aid flow (current US$) in Finland?
Provide a succinct answer. -8.11e+06. In the year 2001, what is the difference between the Aid flow (current US$) in Greece and Aid flow (current US$) in Luxembourg?
Offer a terse response. 7.93e+06. In the year 2001, what is the difference between the Aid flow (current US$) of Greece and Aid flow (current US$) of Australia?
Your response must be concise. 8.81e+06. In the year 2001, what is the difference between the Aid flow (current US$) of Greece and Aid flow (current US$) of Finland?
Give a very brief answer. 4.55e+06. In the year 2001, what is the difference between the Aid flow (current US$) of Luxembourg and Aid flow (current US$) of Australia?
Provide a succinct answer. 8.80e+05. In the year 2001, what is the difference between the Aid flow (current US$) in Luxembourg and Aid flow (current US$) in Finland?
Offer a terse response. -3.38e+06. In the year 2001, what is the difference between the Aid flow (current US$) in Australia and Aid flow (current US$) in Finland?
Offer a very short reply. -4.26e+06. In the year 2002, what is the difference between the Aid flow (current US$) in Greece and Aid flow (current US$) in Luxembourg?
Your answer should be very brief. 5.15e+06. In the year 2002, what is the difference between the Aid flow (current US$) in Greece and Aid flow (current US$) in Australia?
Keep it short and to the point. 5.72e+06. In the year 2002, what is the difference between the Aid flow (current US$) in Greece and Aid flow (current US$) in Finland?
Provide a short and direct response. 9.50e+05. In the year 2002, what is the difference between the Aid flow (current US$) of Luxembourg and Aid flow (current US$) of Australia?
Ensure brevity in your answer.  5.70e+05. In the year 2002, what is the difference between the Aid flow (current US$) of Luxembourg and Aid flow (current US$) of Finland?
Provide a succinct answer. -4.20e+06. In the year 2002, what is the difference between the Aid flow (current US$) in Australia and Aid flow (current US$) in Finland?
Keep it short and to the point. -4.77e+06. In the year 2003, what is the difference between the Aid flow (current US$) in Greece and Aid flow (current US$) in Luxembourg?
Offer a very short reply. 4.97e+06. In the year 2003, what is the difference between the Aid flow (current US$) in Greece and Aid flow (current US$) in Australia?
Offer a terse response. 5.30e+06. In the year 2003, what is the difference between the Aid flow (current US$) of Greece and Aid flow (current US$) of Finland?
Offer a very short reply. 6.50e+05. In the year 2003, what is the difference between the Aid flow (current US$) in Luxembourg and Aid flow (current US$) in Australia?
Your answer should be compact. 3.30e+05. In the year 2003, what is the difference between the Aid flow (current US$) in Luxembourg and Aid flow (current US$) in Finland?
Give a very brief answer. -4.32e+06. In the year 2003, what is the difference between the Aid flow (current US$) of Australia and Aid flow (current US$) of Finland?
Make the answer very short. -4.65e+06. In the year 2004, what is the difference between the Aid flow (current US$) of Greece and Aid flow (current US$) of Luxembourg?
Your answer should be compact. 6.52e+06. In the year 2004, what is the difference between the Aid flow (current US$) in Greece and Aid flow (current US$) in Australia?
Keep it short and to the point. 7.16e+06. In the year 2004, what is the difference between the Aid flow (current US$) of Luxembourg and Aid flow (current US$) of Australia?
Provide a short and direct response. 6.40e+05. In the year 2004, what is the difference between the Aid flow (current US$) in Luxembourg and Aid flow (current US$) in Finland?
Offer a very short reply. -6.34e+06. In the year 2004, what is the difference between the Aid flow (current US$) in Australia and Aid flow (current US$) in Finland?
Your response must be concise. -6.98e+06. In the year 2005, what is the difference between the Aid flow (current US$) of Greece and Aid flow (current US$) of Luxembourg?
Your answer should be very brief. 9.20e+05. In the year 2005, what is the difference between the Aid flow (current US$) in Greece and Aid flow (current US$) in Australia?
Offer a terse response. 1.26e+06. In the year 2005, what is the difference between the Aid flow (current US$) of Greece and Aid flow (current US$) of Finland?
Make the answer very short. -4.73e+06. In the year 2005, what is the difference between the Aid flow (current US$) in Luxembourg and Aid flow (current US$) in Australia?
Provide a short and direct response. 3.40e+05. In the year 2005, what is the difference between the Aid flow (current US$) in Luxembourg and Aid flow (current US$) in Finland?
Your answer should be very brief. -5.65e+06. In the year 2005, what is the difference between the Aid flow (current US$) in Australia and Aid flow (current US$) in Finland?
Keep it short and to the point. -5.99e+06. What is the ratio of the Aid flow (current US$) in Greece in 1998 to that in 1999?
Keep it short and to the point. 11.2. What is the ratio of the Aid flow (current US$) of Luxembourg in 1998 to that in 1999?
Keep it short and to the point. 0.95. What is the ratio of the Aid flow (current US$) in Finland in 1998 to that in 1999?
Offer a very short reply. 0.99. What is the ratio of the Aid flow (current US$) in Greece in 1998 to that in 2000?
Offer a terse response. 3.52. What is the ratio of the Aid flow (current US$) of Luxembourg in 1998 to that in 2000?
Offer a very short reply. 1.12. What is the ratio of the Aid flow (current US$) in Australia in 1998 to that in 2000?
Your answer should be compact. 1. What is the ratio of the Aid flow (current US$) in Finland in 1998 to that in 2000?
Offer a terse response. 1.09. What is the ratio of the Aid flow (current US$) of Greece in 1998 to that in 2001?
Make the answer very short. 2.51. What is the ratio of the Aid flow (current US$) of Luxembourg in 1998 to that in 2001?
Provide a succinct answer. 1.54. What is the ratio of the Aid flow (current US$) of Finland in 1998 to that in 2001?
Provide a short and direct response. 2.07. What is the ratio of the Aid flow (current US$) of Greece in 1998 to that in 2002?
Keep it short and to the point. 3.87. What is the ratio of the Aid flow (current US$) in Luxembourg in 1998 to that in 2002?
Keep it short and to the point. 2.36. What is the ratio of the Aid flow (current US$) of Finland in 1998 to that in 2002?
Keep it short and to the point. 1.85. What is the ratio of the Aid flow (current US$) in Greece in 1998 to that in 2003?
Provide a succinct answer. 4.18. What is the ratio of the Aid flow (current US$) of Luxembourg in 1998 to that in 2003?
Offer a terse response. 4.03. What is the ratio of the Aid flow (current US$) in Australia in 1998 to that in 2003?
Give a very brief answer. 1. What is the ratio of the Aid flow (current US$) of Finland in 1998 to that in 2003?
Give a very brief answer. 1.9. What is the ratio of the Aid flow (current US$) in Greece in 1998 to that in 2004?
Make the answer very short. 3.09. What is the ratio of the Aid flow (current US$) of Luxembourg in 1998 to that in 2004?
Provide a short and direct response. 2.11. What is the ratio of the Aid flow (current US$) in Finland in 1998 to that in 2004?
Keep it short and to the point. 1.26. What is the ratio of the Aid flow (current US$) of Greece in 1998 to that in 2005?
Your response must be concise. 17.46. What is the ratio of the Aid flow (current US$) in Luxembourg in 1998 to that in 2005?
Ensure brevity in your answer.  3.91. What is the ratio of the Aid flow (current US$) of Australia in 1998 to that in 2005?
Make the answer very short. 1. What is the ratio of the Aid flow (current US$) in Finland in 1998 to that in 2005?
Give a very brief answer. 1.47. What is the ratio of the Aid flow (current US$) in Greece in 1999 to that in 2000?
Provide a succinct answer. 0.31. What is the ratio of the Aid flow (current US$) in Luxembourg in 1999 to that in 2000?
Provide a short and direct response. 1.18. What is the ratio of the Aid flow (current US$) in Finland in 1999 to that in 2000?
Provide a succinct answer. 1.1. What is the ratio of the Aid flow (current US$) in Greece in 1999 to that in 2001?
Your answer should be very brief. 0.22. What is the ratio of the Aid flow (current US$) of Luxembourg in 1999 to that in 2001?
Offer a terse response. 1.62. What is the ratio of the Aid flow (current US$) in Australia in 1999 to that in 2001?
Ensure brevity in your answer.  2. What is the ratio of the Aid flow (current US$) of Finland in 1999 to that in 2001?
Provide a short and direct response. 2.1. What is the ratio of the Aid flow (current US$) of Greece in 1999 to that in 2002?
Provide a short and direct response. 0.35. What is the ratio of the Aid flow (current US$) in Luxembourg in 1999 to that in 2002?
Offer a terse response. 2.48. What is the ratio of the Aid flow (current US$) of Australia in 1999 to that in 2002?
Give a very brief answer. 2. What is the ratio of the Aid flow (current US$) of Finland in 1999 to that in 2002?
Provide a short and direct response. 1.87. What is the ratio of the Aid flow (current US$) in Greece in 1999 to that in 2003?
Provide a succinct answer. 0.37. What is the ratio of the Aid flow (current US$) of Luxembourg in 1999 to that in 2003?
Give a very brief answer. 4.24. What is the ratio of the Aid flow (current US$) in Finland in 1999 to that in 2003?
Ensure brevity in your answer.  1.92. What is the ratio of the Aid flow (current US$) in Greece in 1999 to that in 2004?
Your answer should be very brief. 0.28. What is the ratio of the Aid flow (current US$) of Luxembourg in 1999 to that in 2004?
Give a very brief answer. 2.22. What is the ratio of the Aid flow (current US$) in Australia in 1999 to that in 2004?
Keep it short and to the point. 2. What is the ratio of the Aid flow (current US$) of Finland in 1999 to that in 2004?
Your response must be concise. 1.28. What is the ratio of the Aid flow (current US$) of Greece in 1999 to that in 2005?
Keep it short and to the point. 1.56. What is the ratio of the Aid flow (current US$) in Luxembourg in 1999 to that in 2005?
Give a very brief answer. 4.11. What is the ratio of the Aid flow (current US$) of Finland in 1999 to that in 2005?
Your answer should be very brief. 1.49. What is the ratio of the Aid flow (current US$) of Greece in 2000 to that in 2001?
Keep it short and to the point. 0.71. What is the ratio of the Aid flow (current US$) of Luxembourg in 2000 to that in 2001?
Make the answer very short. 1.37. What is the ratio of the Aid flow (current US$) of Australia in 2000 to that in 2001?
Keep it short and to the point. 1. What is the ratio of the Aid flow (current US$) of Finland in 2000 to that in 2001?
Your answer should be very brief. 1.9. What is the ratio of the Aid flow (current US$) in Greece in 2000 to that in 2002?
Provide a succinct answer. 1.1. What is the ratio of the Aid flow (current US$) in Luxembourg in 2000 to that in 2002?
Offer a terse response. 2.1. What is the ratio of the Aid flow (current US$) in Australia in 2000 to that in 2002?
Your answer should be compact. 1. What is the ratio of the Aid flow (current US$) of Finland in 2000 to that in 2002?
Provide a succinct answer. 1.7. What is the ratio of the Aid flow (current US$) of Greece in 2000 to that in 2003?
Make the answer very short. 1.19. What is the ratio of the Aid flow (current US$) in Luxembourg in 2000 to that in 2003?
Provide a succinct answer. 3.59. What is the ratio of the Aid flow (current US$) in Australia in 2000 to that in 2003?
Ensure brevity in your answer.  1. What is the ratio of the Aid flow (current US$) of Finland in 2000 to that in 2003?
Provide a succinct answer. 1.74. What is the ratio of the Aid flow (current US$) in Greece in 2000 to that in 2004?
Provide a short and direct response. 0.88. What is the ratio of the Aid flow (current US$) in Luxembourg in 2000 to that in 2004?
Keep it short and to the point. 1.88. What is the ratio of the Aid flow (current US$) of Australia in 2000 to that in 2004?
Your response must be concise. 1. What is the ratio of the Aid flow (current US$) in Finland in 2000 to that in 2004?
Provide a succinct answer. 1.16. What is the ratio of the Aid flow (current US$) of Greece in 2000 to that in 2005?
Offer a very short reply. 4.96. What is the ratio of the Aid flow (current US$) of Luxembourg in 2000 to that in 2005?
Offer a terse response. 3.49. What is the ratio of the Aid flow (current US$) in Finland in 2000 to that in 2005?
Your answer should be compact. 1.35. What is the ratio of the Aid flow (current US$) of Greece in 2001 to that in 2002?
Provide a succinct answer. 1.54. What is the ratio of the Aid flow (current US$) in Luxembourg in 2001 to that in 2002?
Ensure brevity in your answer.  1.53. What is the ratio of the Aid flow (current US$) in Australia in 2001 to that in 2002?
Offer a very short reply. 1. What is the ratio of the Aid flow (current US$) in Finland in 2001 to that in 2002?
Make the answer very short. 0.89. What is the ratio of the Aid flow (current US$) in Greece in 2001 to that in 2003?
Offer a very short reply. 1.66. What is the ratio of the Aid flow (current US$) of Luxembourg in 2001 to that in 2003?
Offer a terse response. 2.62. What is the ratio of the Aid flow (current US$) of Finland in 2001 to that in 2003?
Offer a terse response. 0.92. What is the ratio of the Aid flow (current US$) of Greece in 2001 to that in 2004?
Keep it short and to the point. 1.23. What is the ratio of the Aid flow (current US$) of Luxembourg in 2001 to that in 2004?
Offer a very short reply. 1.37. What is the ratio of the Aid flow (current US$) in Australia in 2001 to that in 2004?
Your response must be concise. 1. What is the ratio of the Aid flow (current US$) of Finland in 2001 to that in 2004?
Make the answer very short. 0.61. What is the ratio of the Aid flow (current US$) of Greece in 2001 to that in 2005?
Provide a short and direct response. 6.94. What is the ratio of the Aid flow (current US$) in Luxembourg in 2001 to that in 2005?
Offer a very short reply. 2.54. What is the ratio of the Aid flow (current US$) in Australia in 2001 to that in 2005?
Keep it short and to the point. 1. What is the ratio of the Aid flow (current US$) of Finland in 2001 to that in 2005?
Your answer should be very brief. 0.71. What is the ratio of the Aid flow (current US$) in Greece in 2002 to that in 2003?
Give a very brief answer. 1.08. What is the ratio of the Aid flow (current US$) in Luxembourg in 2002 to that in 2003?
Provide a short and direct response. 1.71. What is the ratio of the Aid flow (current US$) in Australia in 2002 to that in 2003?
Your response must be concise. 1. What is the ratio of the Aid flow (current US$) in Finland in 2002 to that in 2003?
Offer a very short reply. 1.03. What is the ratio of the Aid flow (current US$) in Greece in 2002 to that in 2004?
Your answer should be very brief. 0.8. What is the ratio of the Aid flow (current US$) in Luxembourg in 2002 to that in 2004?
Provide a succinct answer. 0.89. What is the ratio of the Aid flow (current US$) of Australia in 2002 to that in 2004?
Ensure brevity in your answer.  1. What is the ratio of the Aid flow (current US$) in Finland in 2002 to that in 2004?
Make the answer very short. 0.68. What is the ratio of the Aid flow (current US$) in Greece in 2002 to that in 2005?
Give a very brief answer. 4.51. What is the ratio of the Aid flow (current US$) of Luxembourg in 2002 to that in 2005?
Offer a very short reply. 1.66. What is the ratio of the Aid flow (current US$) in Finland in 2002 to that in 2005?
Your answer should be compact. 0.8. What is the ratio of the Aid flow (current US$) in Greece in 2003 to that in 2004?
Offer a terse response. 0.74. What is the ratio of the Aid flow (current US$) of Luxembourg in 2003 to that in 2004?
Offer a terse response. 0.52. What is the ratio of the Aid flow (current US$) of Greece in 2003 to that in 2005?
Your response must be concise. 4.18. What is the ratio of the Aid flow (current US$) of Luxembourg in 2003 to that in 2005?
Offer a terse response. 0.97. What is the ratio of the Aid flow (current US$) in Australia in 2003 to that in 2005?
Offer a terse response. 1. What is the ratio of the Aid flow (current US$) of Finland in 2003 to that in 2005?
Your answer should be compact. 0.78. What is the ratio of the Aid flow (current US$) in Greece in 2004 to that in 2005?
Provide a short and direct response. 5.65. What is the ratio of the Aid flow (current US$) in Luxembourg in 2004 to that in 2005?
Offer a very short reply. 1.86. What is the ratio of the Aid flow (current US$) in Australia in 2004 to that in 2005?
Your answer should be very brief. 1. What is the ratio of the Aid flow (current US$) in Finland in 2004 to that in 2005?
Offer a terse response. 1.17. What is the difference between the highest and the second highest Aid flow (current US$) of Greece?
Keep it short and to the point. 1.34e+07. What is the difference between the highest and the second highest Aid flow (current US$) in Luxembourg?
Your response must be concise. 7.00e+04. What is the difference between the highest and the second highest Aid flow (current US$) in Finland?
Offer a very short reply. 1.10e+05. What is the difference between the highest and the lowest Aid flow (current US$) in Greece?
Your answer should be very brief. 2.09e+07. What is the difference between the highest and the lowest Aid flow (current US$) of Luxembourg?
Offer a terse response. 1.10e+06. What is the difference between the highest and the lowest Aid flow (current US$) of Finland?
Keep it short and to the point. 4.68e+06. 